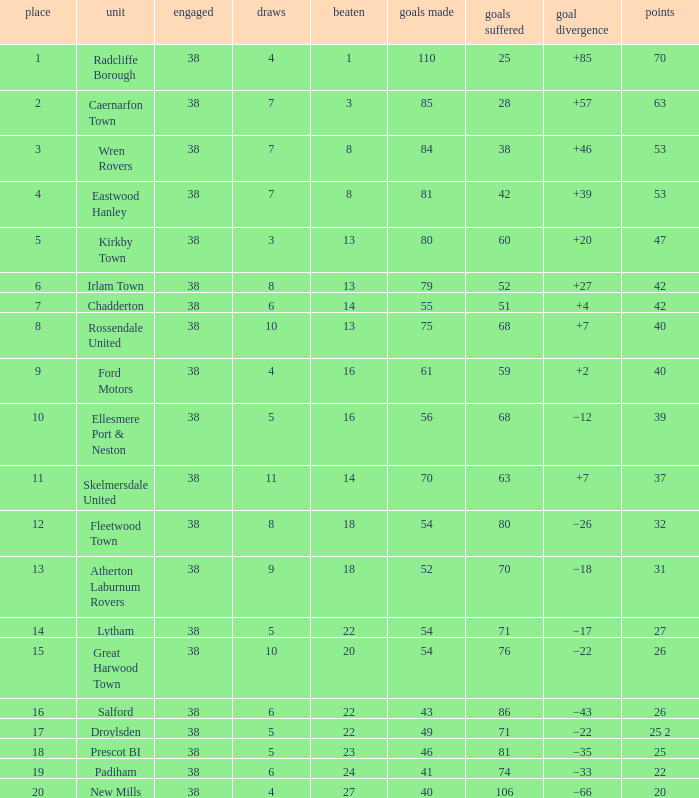How much Drawn has Goals Against larger than 74, and a Lost smaller than 20, and a Played larger than 38? 0.0. 